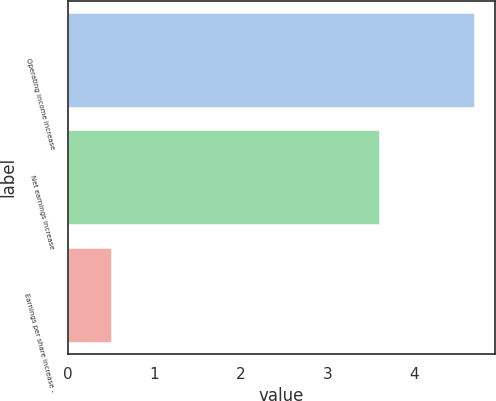<chart> <loc_0><loc_0><loc_500><loc_500><bar_chart><fcel>Operating income increase<fcel>Net earnings increase<fcel>Earnings per share increase -<nl><fcel>4.7<fcel>3.6<fcel>0.5<nl></chart> 